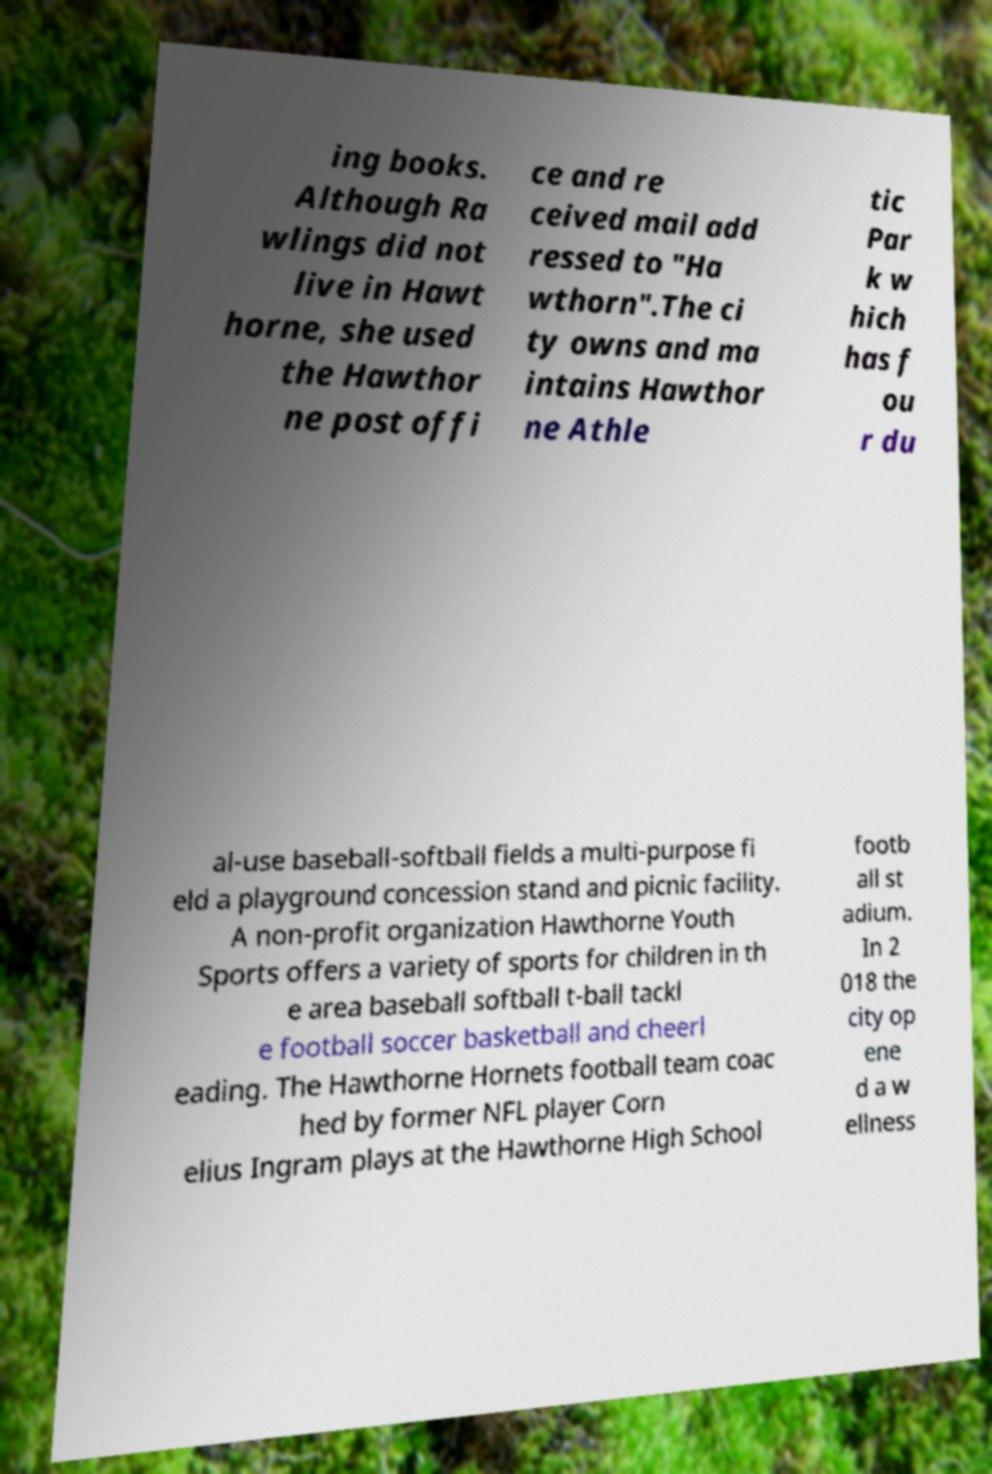Could you assist in decoding the text presented in this image and type it out clearly? ing books. Although Ra wlings did not live in Hawt horne, she used the Hawthor ne post offi ce and re ceived mail add ressed to "Ha wthorn".The ci ty owns and ma intains Hawthor ne Athle tic Par k w hich has f ou r du al-use baseball-softball fields a multi-purpose fi eld a playground concession stand and picnic facility. A non-profit organization Hawthorne Youth Sports offers a variety of sports for children in th e area baseball softball t-ball tackl e football soccer basketball and cheerl eading. The Hawthorne Hornets football team coac hed by former NFL player Corn elius Ingram plays at the Hawthorne High School footb all st adium. In 2 018 the city op ene d a w ellness 